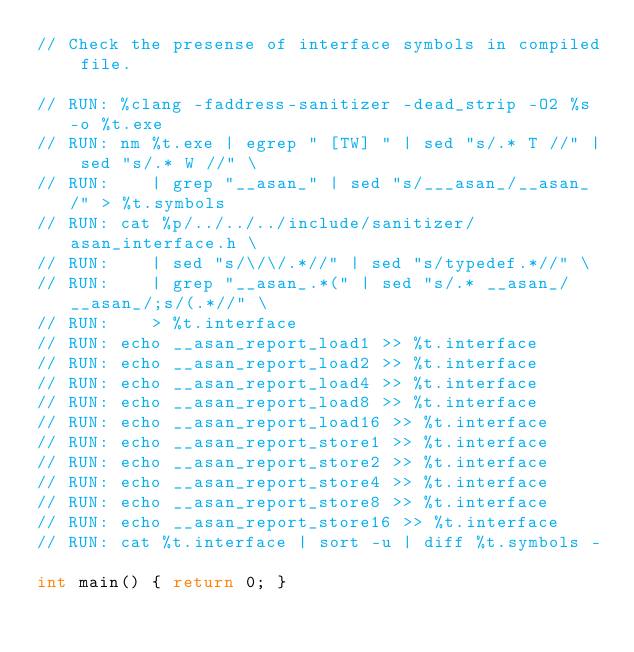Convert code to text. <code><loc_0><loc_0><loc_500><loc_500><_C_>// Check the presense of interface symbols in compiled file.

// RUN: %clang -faddress-sanitizer -dead_strip -O2 %s -o %t.exe
// RUN: nm %t.exe | egrep " [TW] " | sed "s/.* T //" | sed "s/.* W //" \
// RUN:    | grep "__asan_" | sed "s/___asan_/__asan_/" > %t.symbols
// RUN: cat %p/../../../include/sanitizer/asan_interface.h \
// RUN:    | sed "s/\/\/.*//" | sed "s/typedef.*//" \
// RUN:    | grep "__asan_.*(" | sed "s/.* __asan_/__asan_/;s/(.*//" \
// RUN:    > %t.interface
// RUN: echo __asan_report_load1 >> %t.interface
// RUN: echo __asan_report_load2 >> %t.interface
// RUN: echo __asan_report_load4 >> %t.interface
// RUN: echo __asan_report_load8 >> %t.interface
// RUN: echo __asan_report_load16 >> %t.interface
// RUN: echo __asan_report_store1 >> %t.interface
// RUN: echo __asan_report_store2 >> %t.interface
// RUN: echo __asan_report_store4 >> %t.interface
// RUN: echo __asan_report_store8 >> %t.interface
// RUN: echo __asan_report_store16 >> %t.interface
// RUN: cat %t.interface | sort -u | diff %t.symbols -

int main() { return 0; }
</code> 